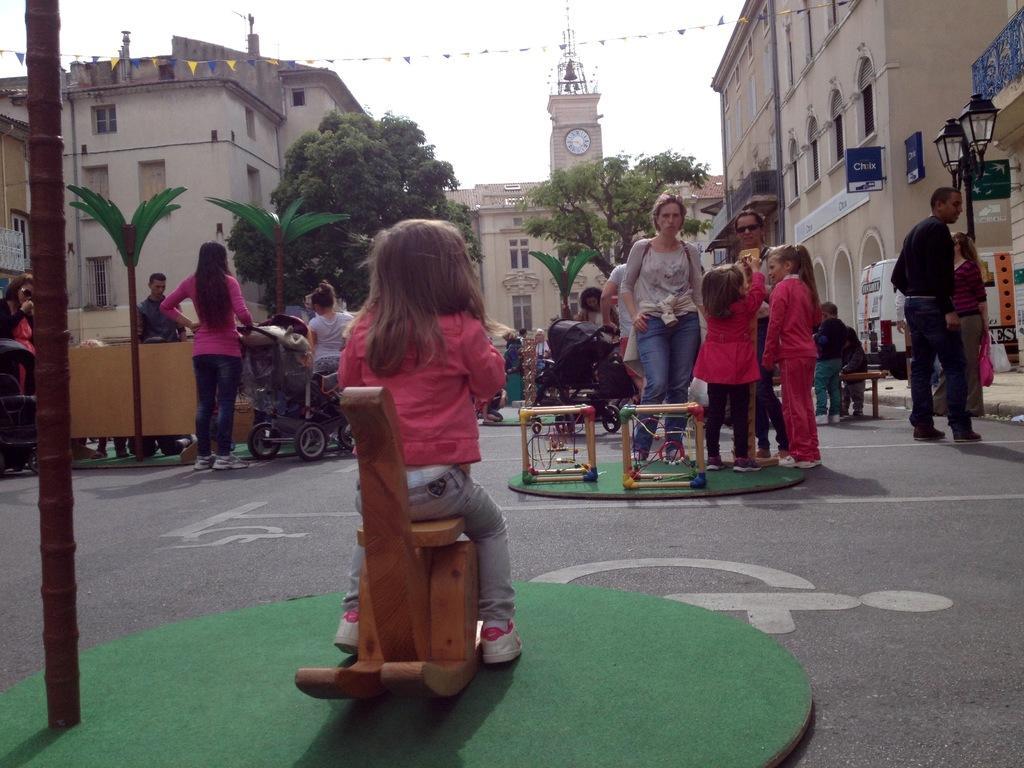Can you describe this image briefly? In this picture we can see a girl is sitting on a wooden toy. On the left side of the girl there is a pole. In front of the girl, there are some objects and a group of people standing and a woman is holding a stroller. Behind the people there are poles, trees, buildings and the sky. On the right side of the people there is a vehicle, boards and a black pole with lights. 